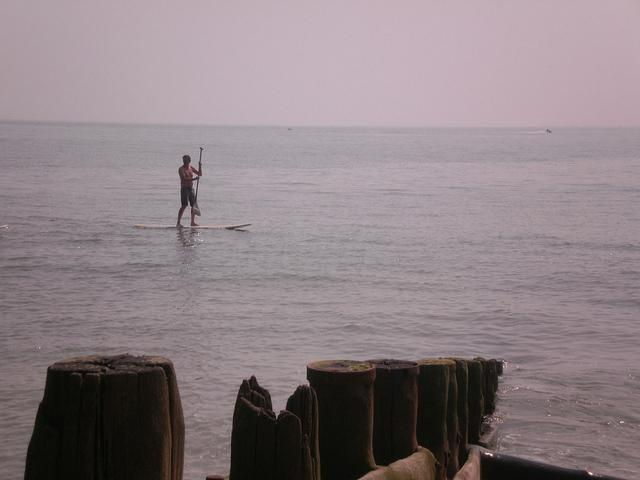Where else would his hand held tool be somewhat suitable? Please explain your reasoning. boat. It is an oar. oars help propel things forward in the water. 